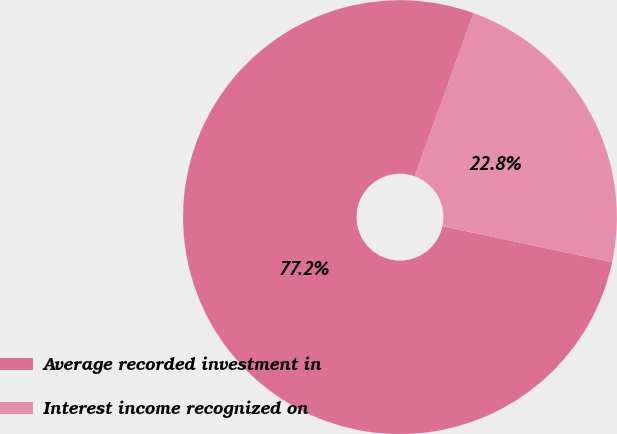<chart> <loc_0><loc_0><loc_500><loc_500><pie_chart><fcel>Average recorded investment in<fcel>Interest income recognized on<nl><fcel>77.18%<fcel>22.82%<nl></chart> 